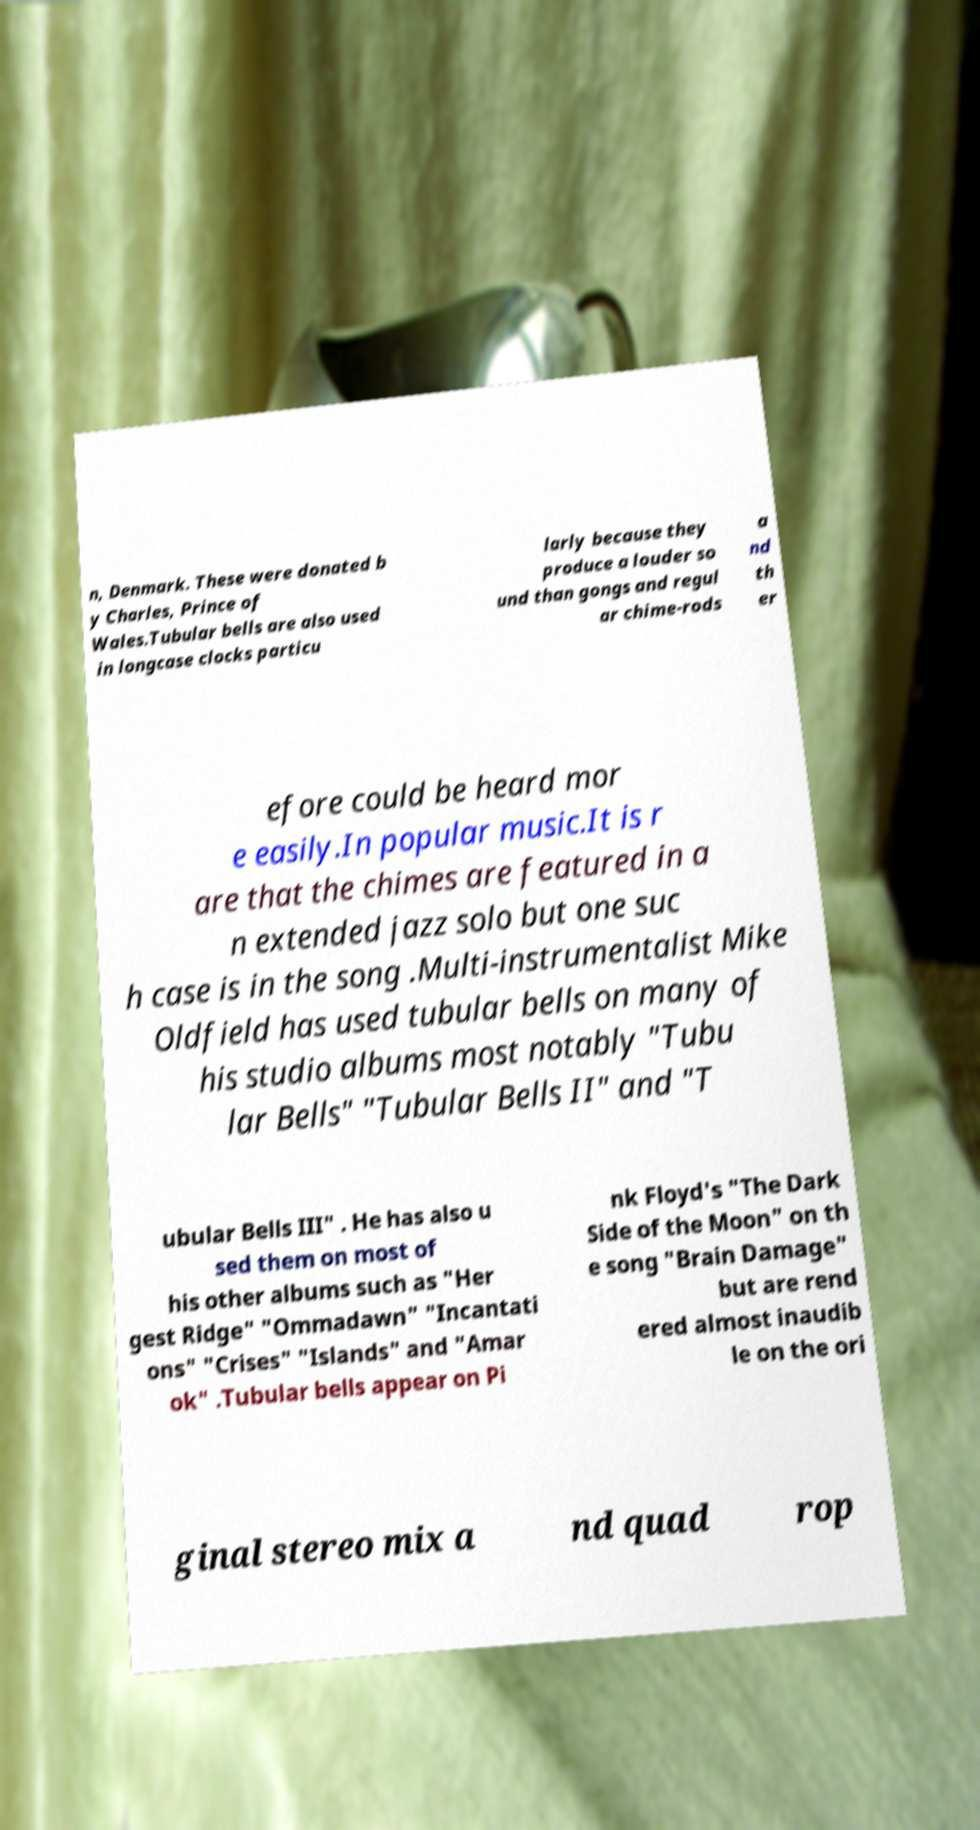What messages or text are displayed in this image? I need them in a readable, typed format. n, Denmark. These were donated b y Charles, Prince of Wales.Tubular bells are also used in longcase clocks particu larly because they produce a louder so und than gongs and regul ar chime-rods a nd th er efore could be heard mor e easily.In popular music.It is r are that the chimes are featured in a n extended jazz solo but one suc h case is in the song .Multi-instrumentalist Mike Oldfield has used tubular bells on many of his studio albums most notably "Tubu lar Bells" "Tubular Bells II" and "T ubular Bells III" . He has also u sed them on most of his other albums such as "Her gest Ridge" "Ommadawn" "Incantati ons" "Crises" "Islands" and "Amar ok" .Tubular bells appear on Pi nk Floyd's "The Dark Side of the Moon" on th e song "Brain Damage" but are rend ered almost inaudib le on the ori ginal stereo mix a nd quad rop 